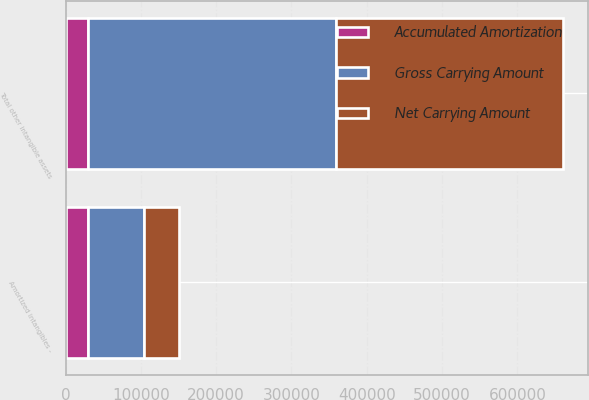<chart> <loc_0><loc_0><loc_500><loc_500><stacked_bar_chart><ecel><fcel>Amortized intangibles -<fcel>Total other intangible assets<nl><fcel>Gross Carrying Amount<fcel>75504<fcel>330286<nl><fcel>Accumulated Amortization<fcel>29188<fcel>29188<nl><fcel>Net Carrying Amount<fcel>46316<fcel>301098<nl></chart> 